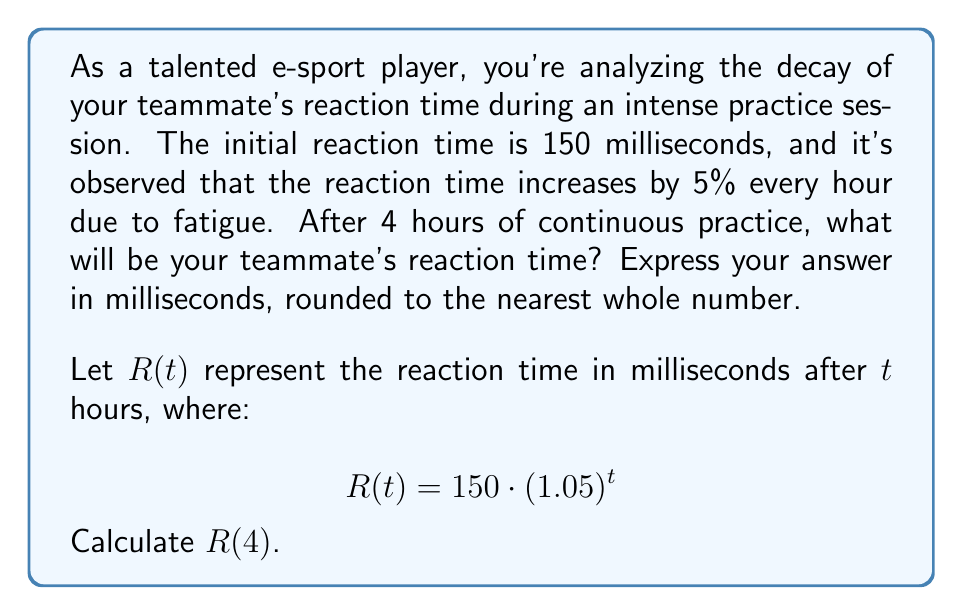Provide a solution to this math problem. To solve this problem, we'll use the given formula and follow these steps:

1) We're given the formula: $R(t) = 150 \cdot (1.05)^t$
   Where $R(t)$ is the reaction time after $t$ hours, 150 ms is the initial reaction time, and 1.05 represents the 5% increase per hour.

2) We need to find $R(4)$, so we'll substitute $t = 4$:

   $R(4) = 150 \cdot (1.05)^4$

3) Now, let's calculate $(1.05)^4$:
   $$(1.05)^4 = 1.05 \cdot 1.05 \cdot 1.05 \cdot 1.05 \approx 1.2155$$

4) Multiply this by 150:
   $$150 \cdot 1.2155 \approx 182.3250$$

5) Rounding to the nearest whole number:
   $$182.3250 \approx 182$$

Therefore, after 4 hours of continuous practice, the teammate's reaction time will be approximately 182 milliseconds.
Answer: 182 milliseconds 